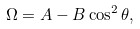<formula> <loc_0><loc_0><loc_500><loc_500>\Omega = A - B \cos ^ { 2 } \theta ,</formula> 